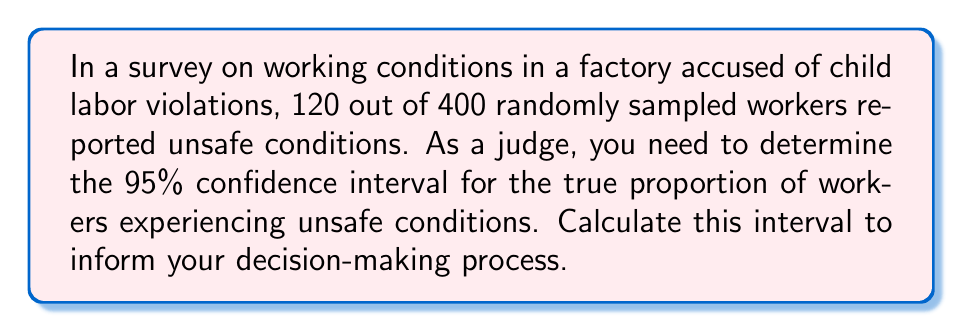Provide a solution to this math problem. To calculate the 95% confidence interval for a proportion, we'll use the formula:

$$ p \pm z \sqrt{\frac{p(1-p)}{n}} $$

Where:
$p$ = sample proportion
$z$ = z-score for 95% confidence level (1.96)
$n$ = sample size

Step 1: Calculate the sample proportion (p)
$p = \frac{120}{400} = 0.3$

Step 2: Calculate the standard error
$SE = \sqrt{\frac{p(1-p)}{n}} = \sqrt{\frac{0.3(1-0.3)}{400}} = 0.0229$

Step 3: Calculate the margin of error
$ME = z \times SE = 1.96 \times 0.0229 = 0.0449$

Step 4: Calculate the confidence interval
Lower bound: $0.3 - 0.0449 = 0.2551$
Upper bound: $0.3 + 0.0449 = 0.3449$

Therefore, the 95% confidence interval is (0.2551, 0.3449) or (25.51%, 34.49%).
Answer: (25.51%, 34.49%) 